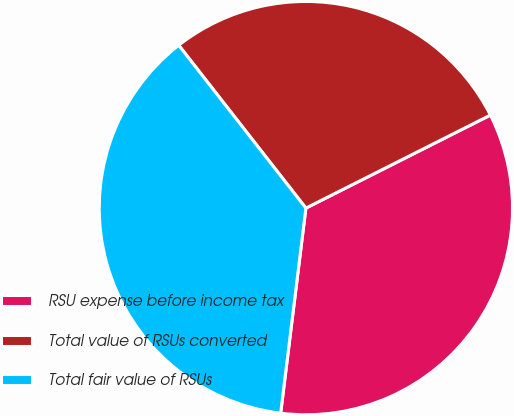<chart> <loc_0><loc_0><loc_500><loc_500><pie_chart><fcel>RSU expense before income tax<fcel>Total value of RSUs converted<fcel>Total fair value of RSUs<nl><fcel>34.38%<fcel>28.12%<fcel>37.5%<nl></chart> 